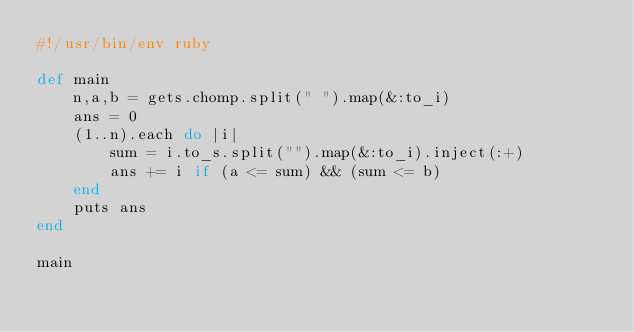Convert code to text. <code><loc_0><loc_0><loc_500><loc_500><_Ruby_>#!/usr/bin/env ruby

def main
    n,a,b = gets.chomp.split(" ").map(&:to_i)
    ans = 0
    (1..n).each do |i|
        sum = i.to_s.split("").map(&:to_i).inject(:+)
        ans += i if (a <= sum) && (sum <= b)
    end
    puts ans    
end

main</code> 